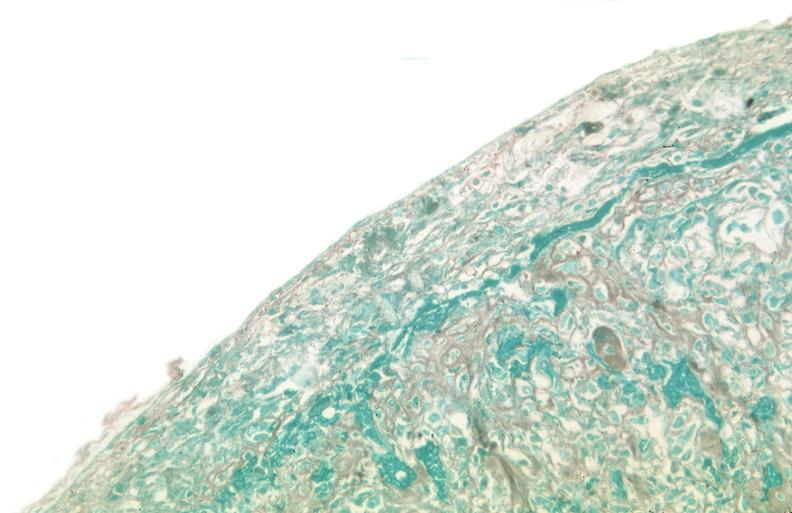does trichrome stain?
Answer the question using a single word or phrase. Yes 